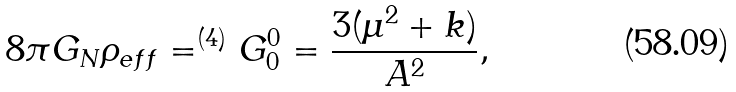Convert formula to latex. <formula><loc_0><loc_0><loc_500><loc_500>8 \pi G _ { N } \rho _ { e f f } = ^ { ( 4 ) } G ^ { 0 } _ { 0 } = \frac { 3 ( \mu ^ { 2 } + k ) } { A ^ { 2 } } ,</formula> 